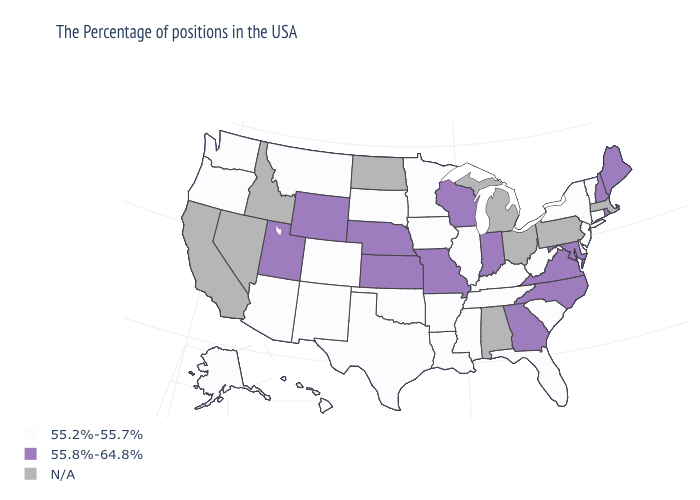Among the states that border Ohio , does Kentucky have the highest value?
Write a very short answer. No. What is the value of Washington?
Concise answer only. 55.2%-55.7%. Does South Carolina have the lowest value in the USA?
Keep it brief. Yes. What is the lowest value in states that border Minnesota?
Give a very brief answer. 55.2%-55.7%. What is the value of New Mexico?
Write a very short answer. 55.2%-55.7%. Which states have the lowest value in the USA?
Short answer required. Vermont, Connecticut, New York, New Jersey, Delaware, South Carolina, West Virginia, Florida, Kentucky, Tennessee, Illinois, Mississippi, Louisiana, Arkansas, Minnesota, Iowa, Oklahoma, Texas, South Dakota, Colorado, New Mexico, Montana, Arizona, Washington, Oregon, Alaska, Hawaii. Name the states that have a value in the range N/A?
Keep it brief. Massachusetts, Pennsylvania, Ohio, Michigan, Alabama, North Dakota, Idaho, Nevada, California. Name the states that have a value in the range 55.2%-55.7%?
Give a very brief answer. Vermont, Connecticut, New York, New Jersey, Delaware, South Carolina, West Virginia, Florida, Kentucky, Tennessee, Illinois, Mississippi, Louisiana, Arkansas, Minnesota, Iowa, Oklahoma, Texas, South Dakota, Colorado, New Mexico, Montana, Arizona, Washington, Oregon, Alaska, Hawaii. Name the states that have a value in the range N/A?
Keep it brief. Massachusetts, Pennsylvania, Ohio, Michigan, Alabama, North Dakota, Idaho, Nevada, California. What is the value of Montana?
Write a very short answer. 55.2%-55.7%. What is the highest value in the MidWest ?
Give a very brief answer. 55.8%-64.8%. What is the value of New Jersey?
Write a very short answer. 55.2%-55.7%. What is the highest value in the USA?
Keep it brief. 55.8%-64.8%. 